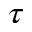Convert formula to latex. <formula><loc_0><loc_0><loc_500><loc_500>\tau</formula> 